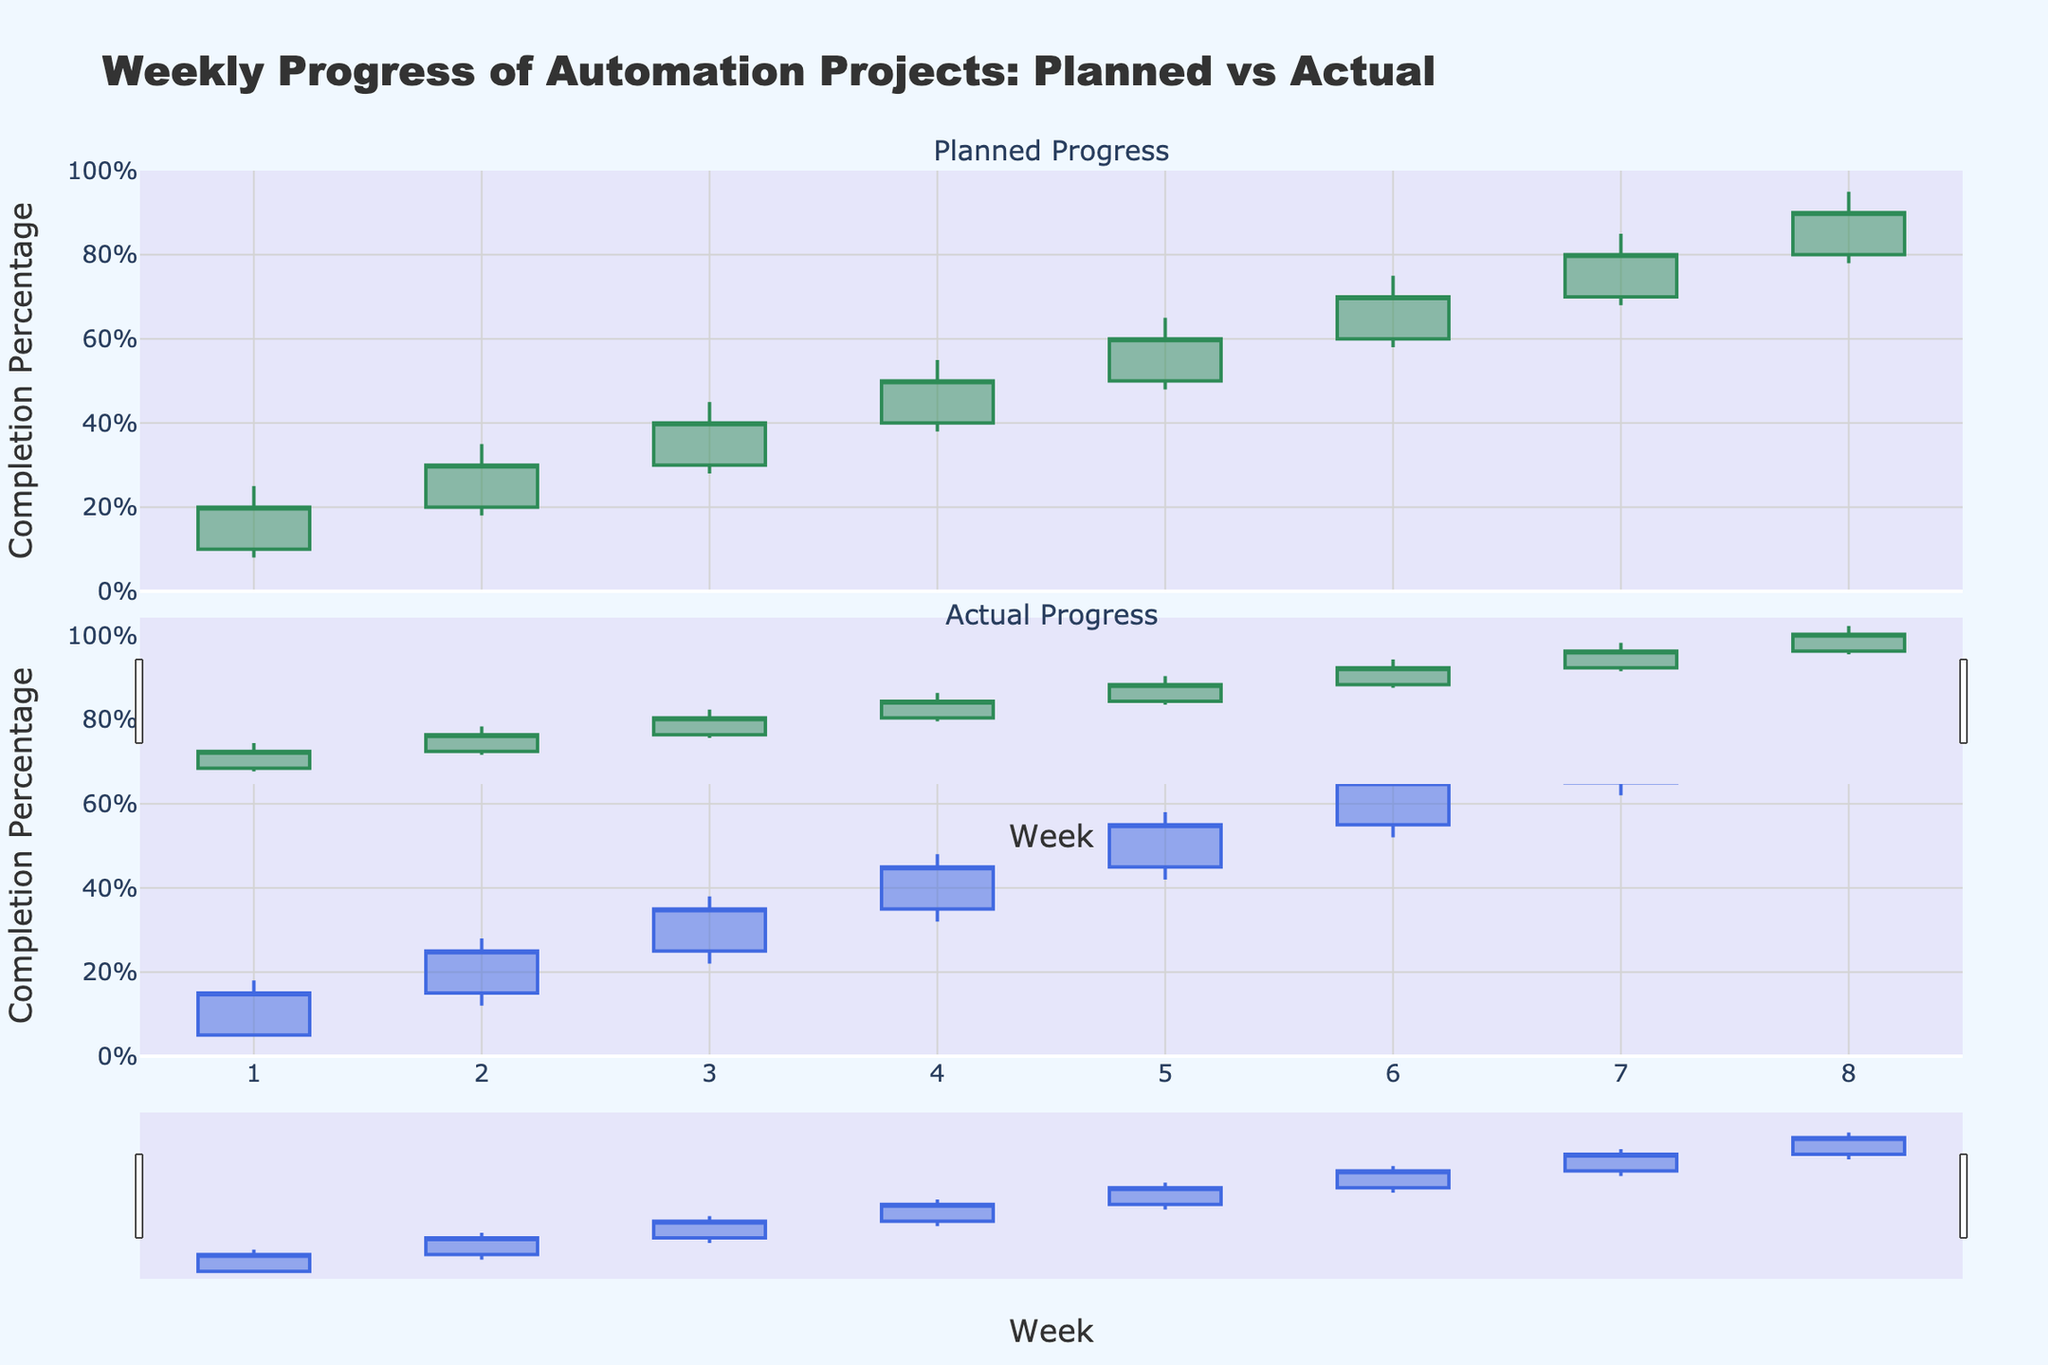What's the title of the figure? The title is displayed at the top of the figure. It reads "Weekly Progress of Automation Projects: Planned vs Actual".
Answer: Weekly Progress of Automation Projects: Planned vs Actual What do the y-axes represent? Both y-axes have a title "Completion Percentage", indicating that they measure the percentage of completion for the projects.
Answer: Completion Percentage In Week 4, did the Financial Reporting Tool project achieve its planned completion percentage? Examine the close values for both "Planned Progress" and "Actual Progress" for Week 4. The planned close is at 50%, while the actual close is 45%, meaning the project did not achieve its planned completion percentage.
Answer: No For Week 6, which had a higher high value: planned or actual progress? Look at Week 6's high values in both subplots. The planned high is 75%, while the actual high is 68%, so planned progress had a higher high value.
Answer: Planned Between which weeks does the planned completion percentage increase the most from the previous week? By comparing close values week-to-week on the planned progress subplot, the largest increase from 20% in Week 1 to 30% in Week 2 is the highest. This results in a 10% increase.
Answer: Week 1 to 2 Which project had the smallest gap between planned and actual close percentages? Calculate the absolute difference between the planned close and the actual close for each week. For Week 8, the planned close is 90% and the actual close is 85%, making the gap 5%, which is the smallest gap.
Answer: Marketing Campaign Scheduler In Week 7, were the planned completion percentages always higher than the actual completion percentages? Compare the open, high, low, and close values for Week 7. The planned values are 70%, 85%, 68%, and 80%, whereas the actual values are 65%, 78%, 62%, and 75%. In all cases, planned values are higher.
Answer: Yes What is the planned completion percentage range for the Quality Control Automation project in Week 7? The range is determined by the high and low values for "Planned Progress". For Week 7, the planned low is 68% and the planned high is 85%.
Answer: 68% to 85% Between Week 4 and Week 5, by how many percentage points did the actual close value change? The actual close in Week 4 is 45% and in Week 5 is 55%. The change is calculated by the difference, which is 55% - 45%.
Answer: 10 percentage points 